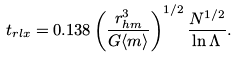<formula> <loc_0><loc_0><loc_500><loc_500>t _ { r l x } = 0 . 1 3 8 \left ( \frac { r _ { h m } ^ { 3 } } { G \langle m \rangle } \right ) ^ { 1 / 2 } \frac { N ^ { 1 / 2 } } { \ln \Lambda } .</formula> 